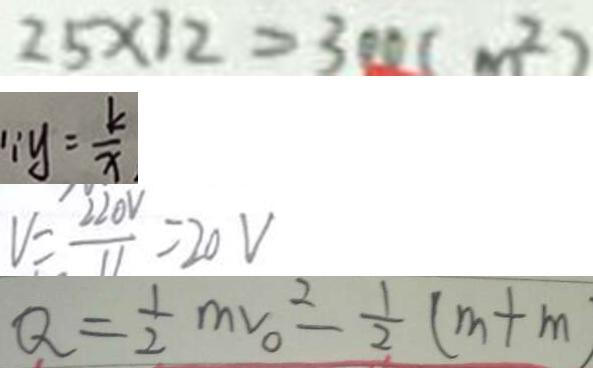<formula> <loc_0><loc_0><loc_500><loc_500>2 5 \times 1 2 = 3 0 0 ( m ^ { 2 } ) 
 \because y = \frac { k } { x } 
 V = \frac { 2 2 0 V } { 1 1 } = 2 0 V 
 Q = \frac { 1 } { 2 } m v _ { 0 } ^ { 2 } - \frac { 1 } { 2 } ( m + m )</formula> 